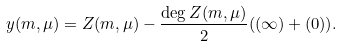Convert formula to latex. <formula><loc_0><loc_0><loc_500><loc_500>y ( m , \mu ) = Z ( m , \mu ) - \frac { \deg Z ( m , \mu ) } { 2 } ( ( \infty ) + ( 0 ) ) .</formula> 